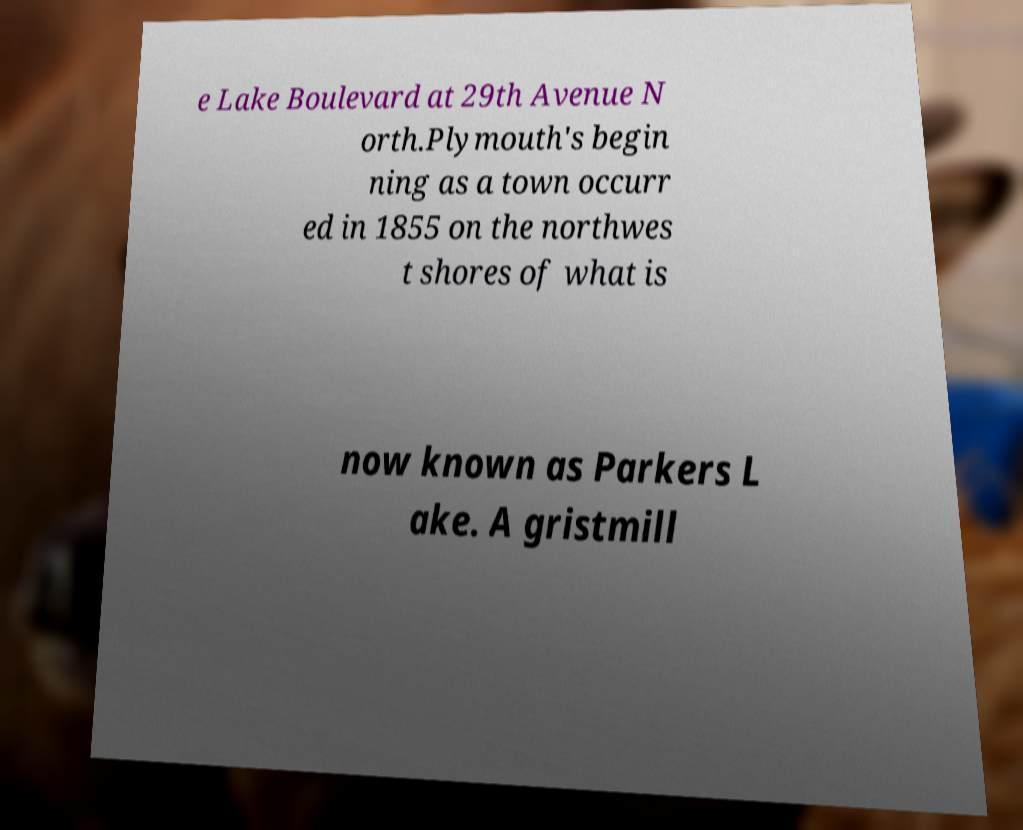Could you assist in decoding the text presented in this image and type it out clearly? e Lake Boulevard at 29th Avenue N orth.Plymouth's begin ning as a town occurr ed in 1855 on the northwes t shores of what is now known as Parkers L ake. A gristmill 